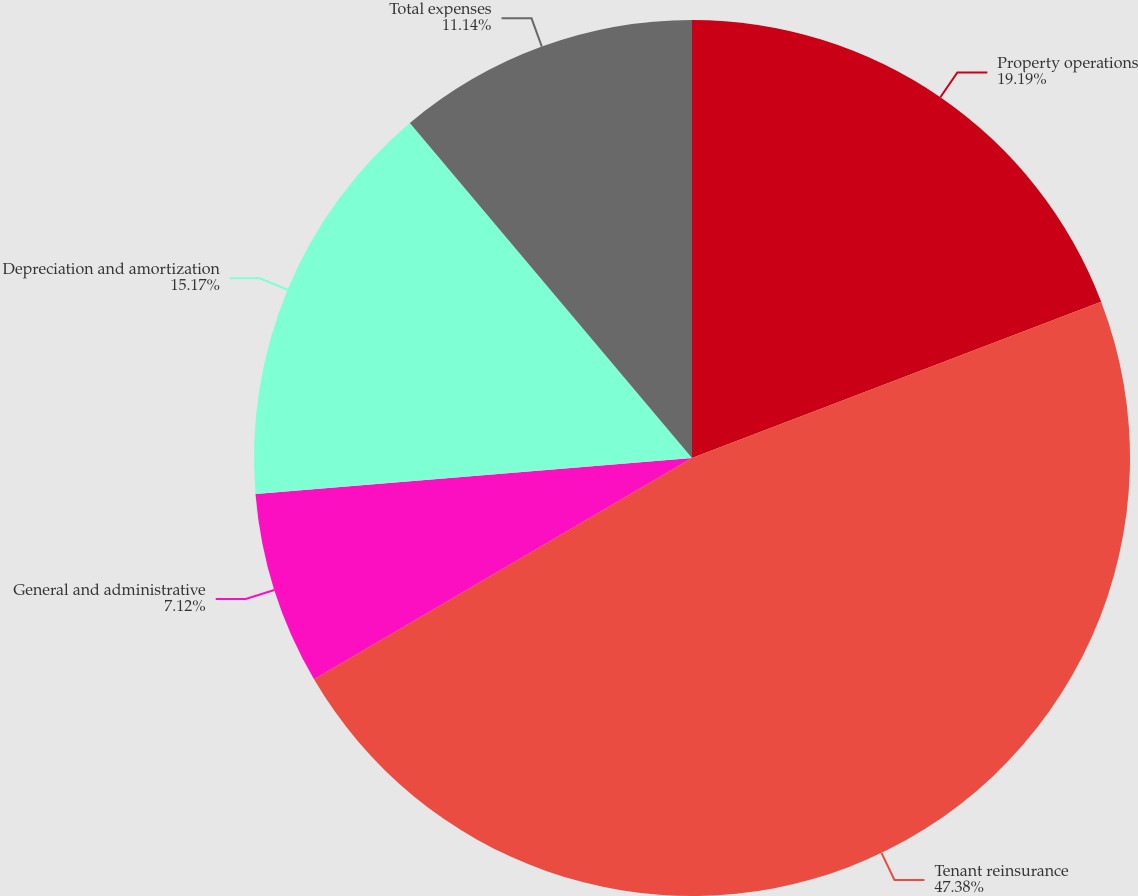<chart> <loc_0><loc_0><loc_500><loc_500><pie_chart><fcel>Property operations<fcel>Tenant reinsurance<fcel>General and administrative<fcel>Depreciation and amortization<fcel>Total expenses<nl><fcel>19.19%<fcel>47.38%<fcel>7.12%<fcel>15.17%<fcel>11.14%<nl></chart> 